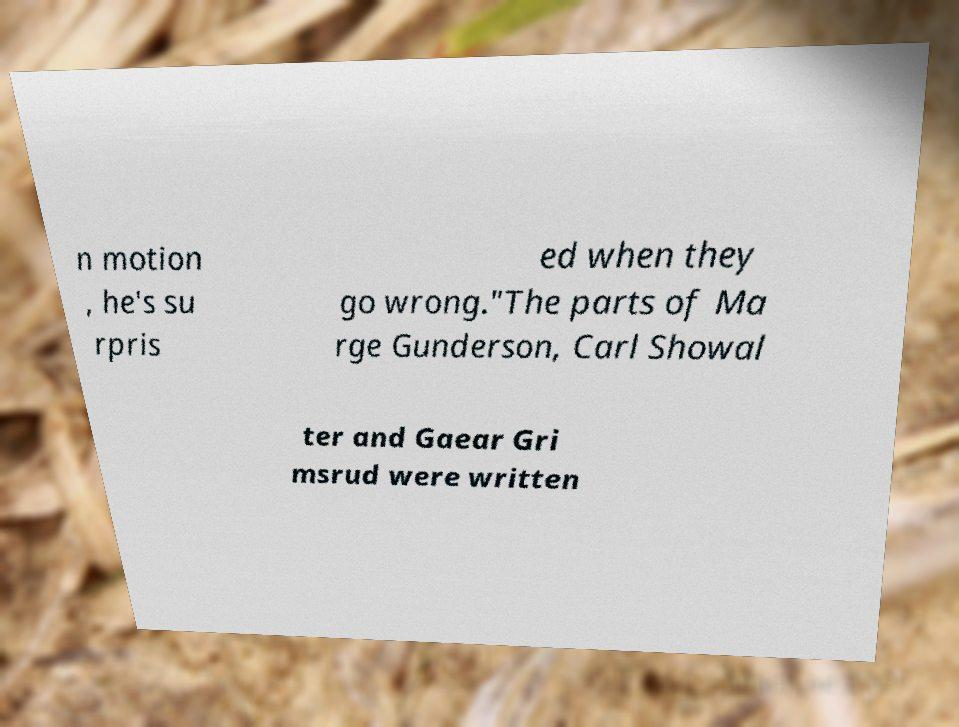Could you extract and type out the text from this image? n motion , he's su rpris ed when they go wrong."The parts of Ma rge Gunderson, Carl Showal ter and Gaear Gri msrud were written 